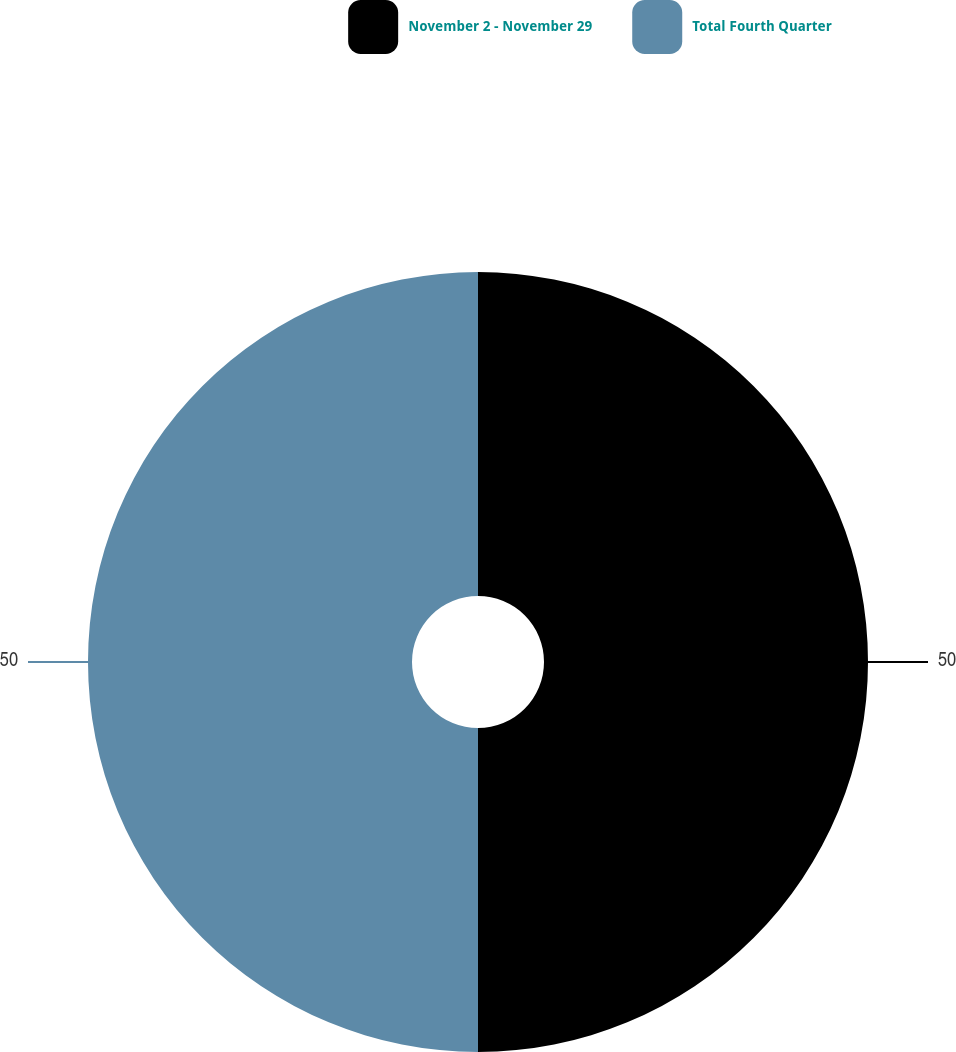Convert chart. <chart><loc_0><loc_0><loc_500><loc_500><pie_chart><fcel>November 2 - November 29<fcel>Total Fourth Quarter<nl><fcel>50.0%<fcel>50.0%<nl></chart> 